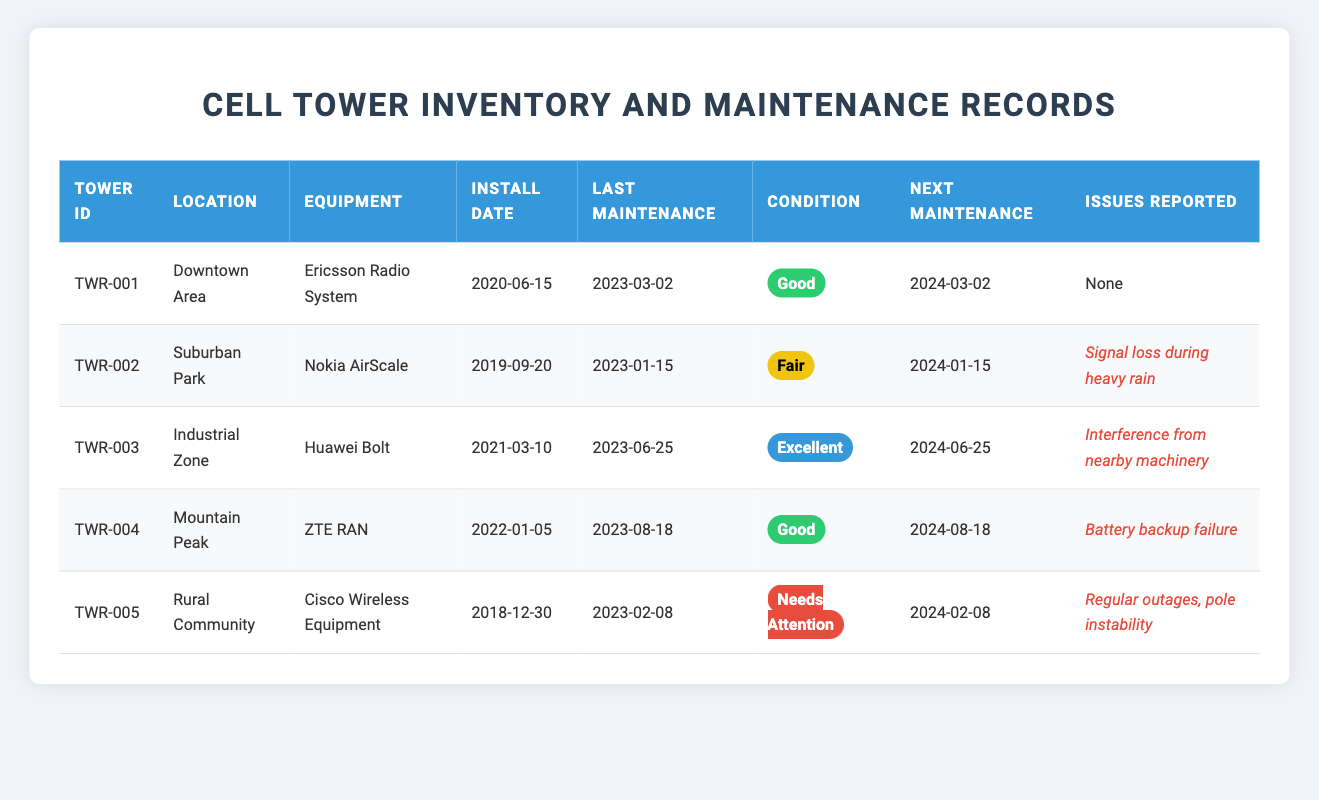What is the equipment used at tower TWR-002? The table shows the details of each tower, and for tower TWR-002, the equipment listed is "Nokia AirScale."
Answer: Nokia AirScale How many towers are in "Good" condition? By checking the condition column, the towers TWR-001 and TWR-004 are both marked as "Good." Thus, there are two towers in this condition.
Answer: 2 What is the next maintenance due date for tower TWR-005? The next maintenance due date for tower TWR-005 is listed in the table as "2024-02-08."
Answer: 2024-02-08 Is there any tower that has reported issues? Looking through the issues reported, towers TWR-002, TWR-003, TWR-004, and TWR-005 have reported issues, which means there are yes instances of reported issues.
Answer: Yes Which tower has the most recent last maintenance date? The last maintenance dates of the towers are: TWR-001 (2023-03-02), TWR-002 (2023-01-15), TWR-003 (2023-06-25), TWR-004 (2023-08-18), and TWR-005 (2023-02-08). The most recent date is "2023-08-18" for TWR-004.
Answer: TWR-004 How many towers have maintenance due in less than six months? Checking the next maintenance dates: TWR-002 (2024-01-15), and TWR-005 (2024-02-08). Both dates are less than six months away from now, so there are two towers.
Answer: 2 What is the average condition rating among the towers? The conditions are categorized into Good, Fair, Excellent, and Needs Attention. Assigning values (Good = 2, Fair = 1, Excellent = 3, Needs Attention = 0), we have: TWR-001 (2), TWR-002 (1), TWR-003 (3), TWR-004 (2), and TWR-005 (0). The average is calculated as (2 + 1 + 3 + 2 + 0) / 5 = 1.6, which suggests a Fair rating overall.
Answer: Fair What equipment is installed at the tower located in the Rural Community? Referring to the location in the table, the tower in the Rural Community (TWR-005) has the equipment "Cisco Wireless Equipment" installed.
Answer: Cisco Wireless Equipment How many towers were installed after January 1, 2020? The towers installed after January 1, 2020, are TWR-001, TWR-003, TWR-004, and TWR-005. Counting these gives us four towers.
Answer: 4 